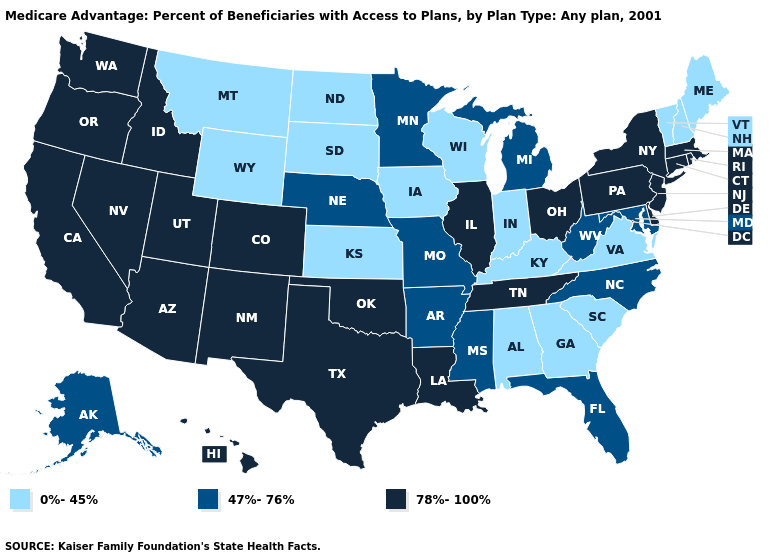Among the states that border Louisiana , which have the lowest value?
Write a very short answer. Arkansas, Mississippi. How many symbols are there in the legend?
Quick response, please. 3. Does the first symbol in the legend represent the smallest category?
Write a very short answer. Yes. What is the value of Ohio?
Quick response, please. 78%-100%. What is the lowest value in the MidWest?
Concise answer only. 0%-45%. Among the states that border Arizona , which have the highest value?
Give a very brief answer. California, Colorado, New Mexico, Nevada, Utah. Does Wyoming have the lowest value in the USA?
Be succinct. Yes. Does North Carolina have a higher value than Colorado?
Answer briefly. No. Which states have the highest value in the USA?
Concise answer only. Arizona, California, Colorado, Connecticut, Delaware, Hawaii, Idaho, Illinois, Louisiana, Massachusetts, New Jersey, New Mexico, Nevada, New York, Ohio, Oklahoma, Oregon, Pennsylvania, Rhode Island, Tennessee, Texas, Utah, Washington. What is the highest value in states that border Idaho?
Quick response, please. 78%-100%. Which states have the lowest value in the MidWest?
Keep it brief. Iowa, Indiana, Kansas, North Dakota, South Dakota, Wisconsin. Which states have the lowest value in the South?
Quick response, please. Alabama, Georgia, Kentucky, South Carolina, Virginia. Name the states that have a value in the range 0%-45%?
Short answer required. Alabama, Georgia, Iowa, Indiana, Kansas, Kentucky, Maine, Montana, North Dakota, New Hampshire, South Carolina, South Dakota, Virginia, Vermont, Wisconsin, Wyoming. Does the map have missing data?
Keep it brief. No. 